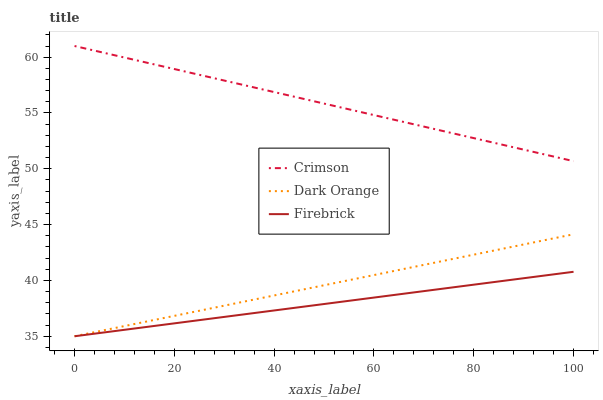Does Firebrick have the minimum area under the curve?
Answer yes or no. Yes. Does Crimson have the maximum area under the curve?
Answer yes or no. Yes. Does Dark Orange have the minimum area under the curve?
Answer yes or no. No. Does Dark Orange have the maximum area under the curve?
Answer yes or no. No. Is Crimson the smoothest?
Answer yes or no. Yes. Is Firebrick the roughest?
Answer yes or no. Yes. Is Dark Orange the smoothest?
Answer yes or no. No. Is Dark Orange the roughest?
Answer yes or no. No. Does Dark Orange have the lowest value?
Answer yes or no. Yes. Does Crimson have the highest value?
Answer yes or no. Yes. Does Dark Orange have the highest value?
Answer yes or no. No. Is Dark Orange less than Crimson?
Answer yes or no. Yes. Is Crimson greater than Firebrick?
Answer yes or no. Yes. Does Firebrick intersect Dark Orange?
Answer yes or no. Yes. Is Firebrick less than Dark Orange?
Answer yes or no. No. Is Firebrick greater than Dark Orange?
Answer yes or no. No. Does Dark Orange intersect Crimson?
Answer yes or no. No. 